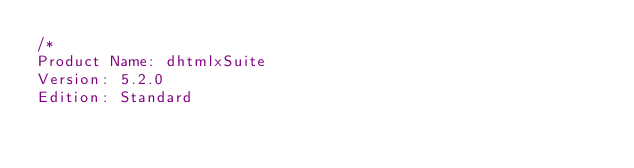Convert code to text. <code><loc_0><loc_0><loc_500><loc_500><_CSS_>/*
Product Name: dhtmlxSuite 
Version: 5.2.0 
Edition: Standard </code> 